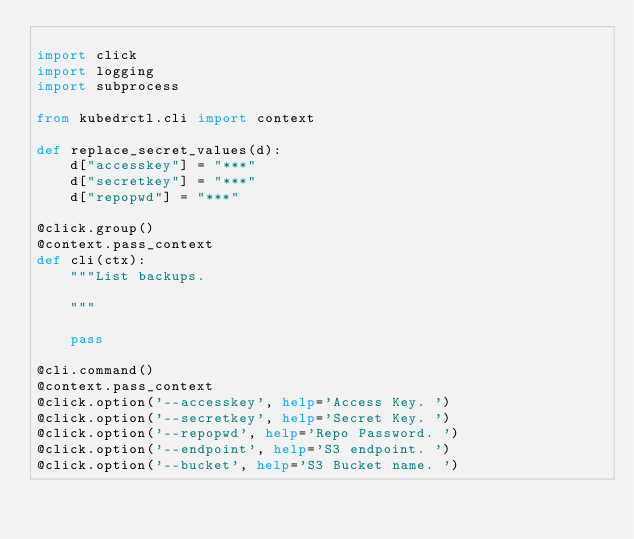<code> <loc_0><loc_0><loc_500><loc_500><_Python_>
import click
import logging
import subprocess

from kubedrctl.cli import context

def replace_secret_values(d):
    d["accesskey"] = "***"
    d["secretkey"] = "***"
    d["repopwd"] = "***"

@click.group()
@context.pass_context
def cli(ctx):
    """List backups.

    """

    pass

@cli.command()
@context.pass_context
@click.option('--accesskey', help='Access Key. ')
@click.option('--secretkey', help='Secret Key. ')
@click.option('--repopwd', help='Repo Password. ')
@click.option('--endpoint', help='S3 endpoint. ')
@click.option('--bucket', help='S3 Bucket name. ')</code> 